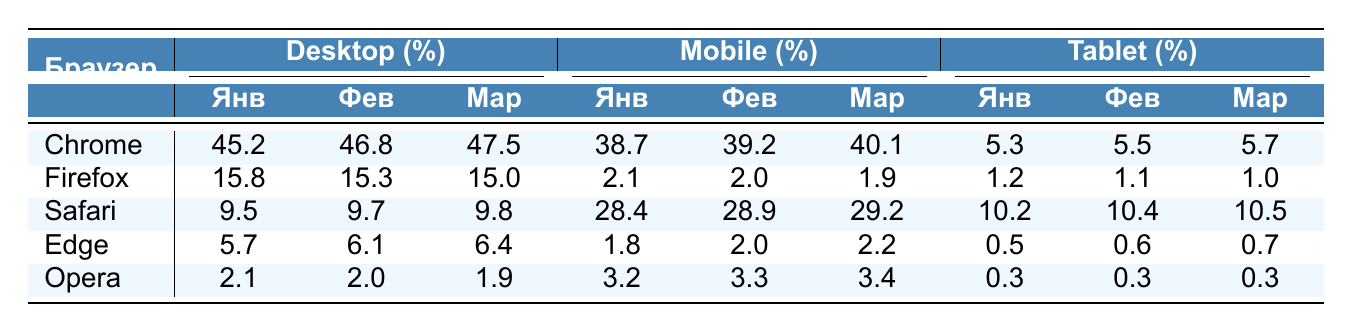What percentage of users accessed the site using Chrome on Mobile in March? From the table, we can find the percentage of users who accessed the site using Chrome on Mobile in March which is listed as 40.1% under the Mobile section for Chrome.
Answer: 40.1% Which browser had the highest percentage of Desktop users in February? Examining the Desktop percentages for February, Chrome has the highest percentage at 46.8%, compared to 15.3% for Firefox, 9.7% for Safari, 6.1% for Edge, and 2.0% for Opera.
Answer: Chrome What is the total percentage of users accessing the site from mobile devices for Safari across all three months? First, sum the percentages for Safari on Mobile: January (28.4) + February (28.9) + March (29.2) = 86.5%. The total percentage is thus 86.5%.
Answer: 86.5% Does Opera have more users on the Tablet than Edge in March? By looking at the values for March, Opera has 0.3% on Tablet while Edge has 0.7%. Since 0.3% is less than 0.7%, Opera does not have more users than Edge on Tablet.
Answer: No What could be inferred about the trend of Firefox usage on Desktop devices from January to March? The percentages for Firefox on Desktop are as follows: January (15.8), February (15.3), and March (15.0). Since there is a decrease from January to February and again to March, it implies a downward trend in usage for Firefox on Desktop devices over the observed months.
Answer: Downward trend What is the overall average percentage of Desktop users for all browsers in January? To calculate the average for Desktop users in January, we add the percentages: 45.2 (Chrome) + 15.8 (Firefox) + 9.5 (Safari) + 5.7 (Edge) + 2.1 (Opera) = 78.3%. There are 5 browsers, so the average is 78.3% / 5 = 15.66%.
Answer: 15.66% Which device type had the lowest percentage across all browsers in February? Looking through the table, for each browser and device type in February, the lowest percentage was for Edge on Tablet with 0.6%. All other devices have higher percentages.
Answer: Tablet What has been the change in percentage of Desktop users for Chrome from January to March? The percentage for Chrome on Desktop in January is 45.2% and in March it is 47.5%. Calculating the change: 47.5% - 45.2% = 2.3%. Thus, there was an increase of 2.3% in Desktop usage for Chrome from January to March.
Answer: Increase of 2.3% 